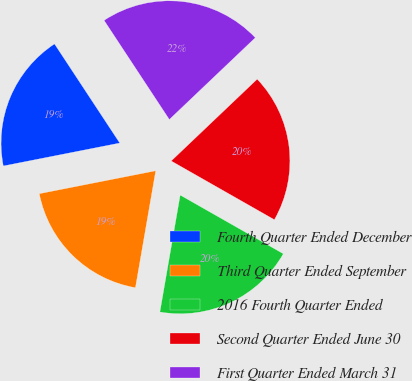Convert chart to OTSL. <chart><loc_0><loc_0><loc_500><loc_500><pie_chart><fcel>Fourth Quarter Ended December<fcel>Third Quarter Ended September<fcel>2016 Fourth Quarter Ended<fcel>Second Quarter Ended June 30<fcel>First Quarter Ended March 31<nl><fcel>18.83%<fcel>19.17%<fcel>19.5%<fcel>20.34%<fcel>22.16%<nl></chart> 